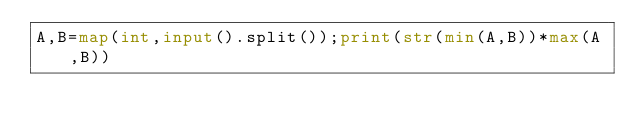Convert code to text. <code><loc_0><loc_0><loc_500><loc_500><_Python_>A,B=map(int,input().split());print(str(min(A,B))*max(A,B))</code> 